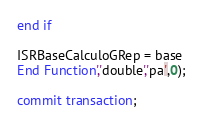Convert code to text. <code><loc_0><loc_0><loc_500><loc_500><_SQL_>end if

ISRBaseCalculoGRep = base
End Function','double','pa',0);

commit transaction;
</code> 